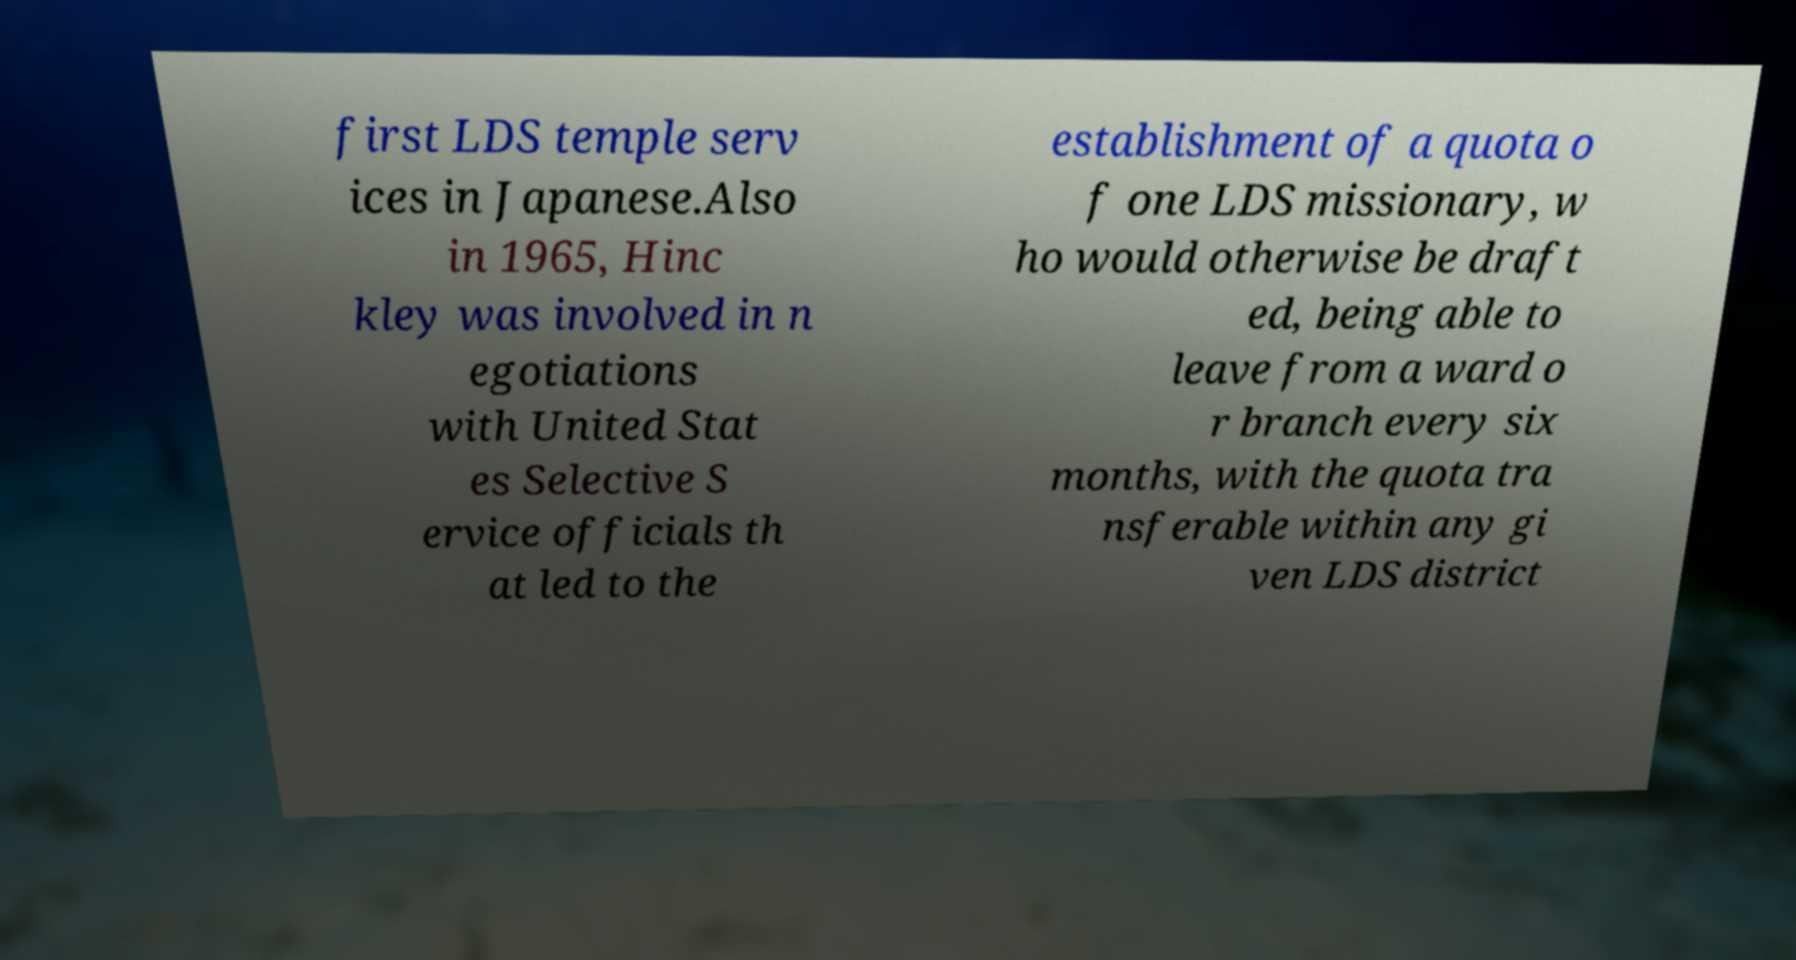Could you extract and type out the text from this image? first LDS temple serv ices in Japanese.Also in 1965, Hinc kley was involved in n egotiations with United Stat es Selective S ervice officials th at led to the establishment of a quota o f one LDS missionary, w ho would otherwise be draft ed, being able to leave from a ward o r branch every six months, with the quota tra nsferable within any gi ven LDS district 